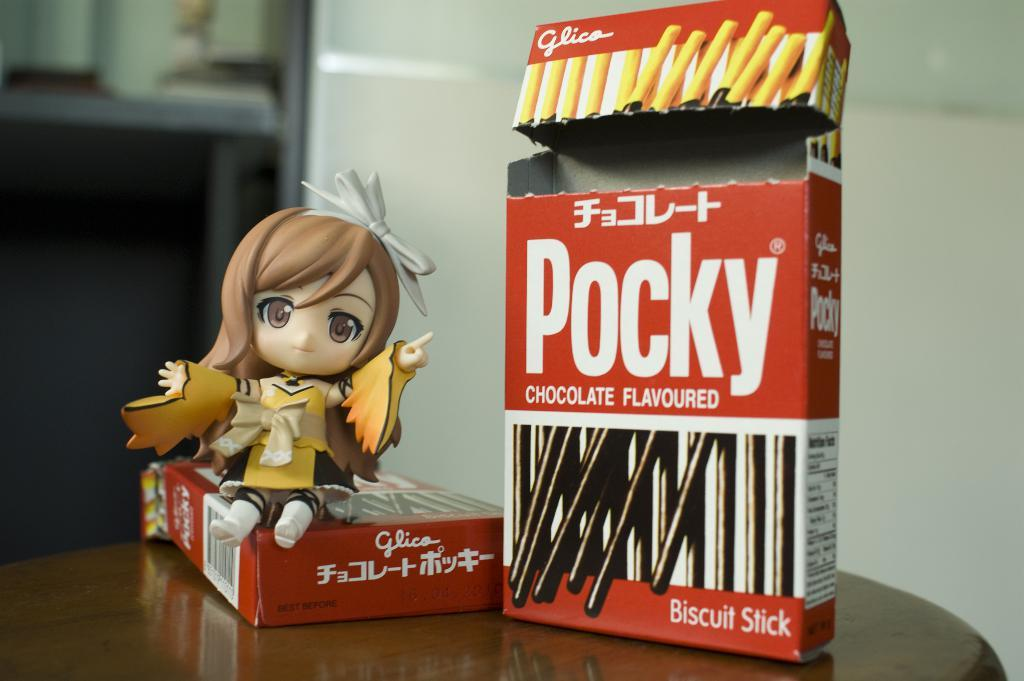How many boxes are present in the image? There are two boxes in the image. What type of toy can be seen in the image? There is a toy of a girl in the image. Where are the objects located in the image? The objects are on a table. What can be seen in the background of the image? There is a wall visible in the background of the image, and it appears blurry. Are there any cent-shaped objects visible in the image? There are no cent-shaped objects present in the image. Is there a volcano erupting in the background of the image? There is no volcano present in the image, and it does not show any eruption. 